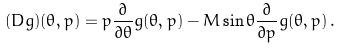<formula> <loc_0><loc_0><loc_500><loc_500>( D g ) ( \theta , p ) = p \frac { \partial } { \partial \theta } g ( \theta , p ) - M \sin \theta \frac { \partial } { \partial p } g ( \theta , p ) \, .</formula> 